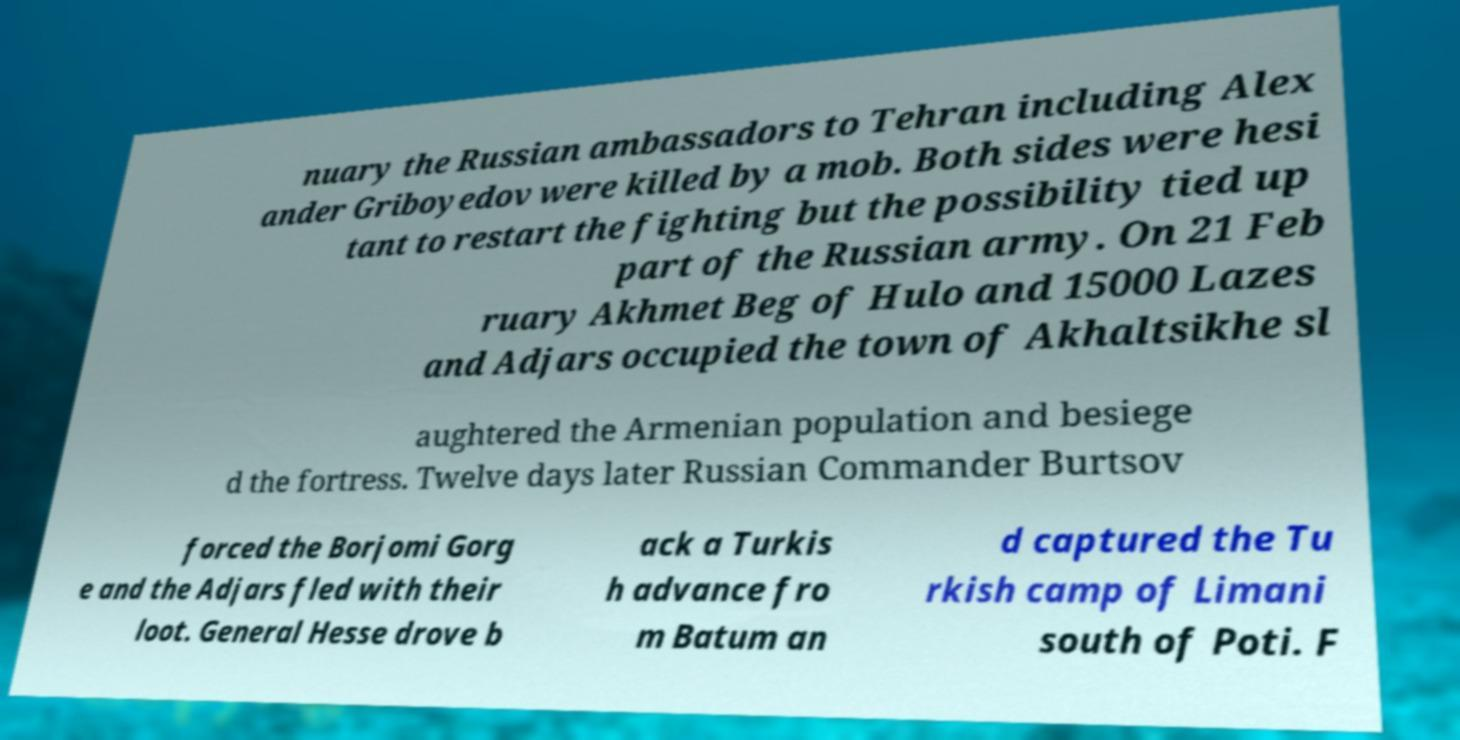For documentation purposes, I need the text within this image transcribed. Could you provide that? nuary the Russian ambassadors to Tehran including Alex ander Griboyedov were killed by a mob. Both sides were hesi tant to restart the fighting but the possibility tied up part of the Russian army. On 21 Feb ruary Akhmet Beg of Hulo and 15000 Lazes and Adjars occupied the town of Akhaltsikhe sl aughtered the Armenian population and besiege d the fortress. Twelve days later Russian Commander Burtsov forced the Borjomi Gorg e and the Adjars fled with their loot. General Hesse drove b ack a Turkis h advance fro m Batum an d captured the Tu rkish camp of Limani south of Poti. F 